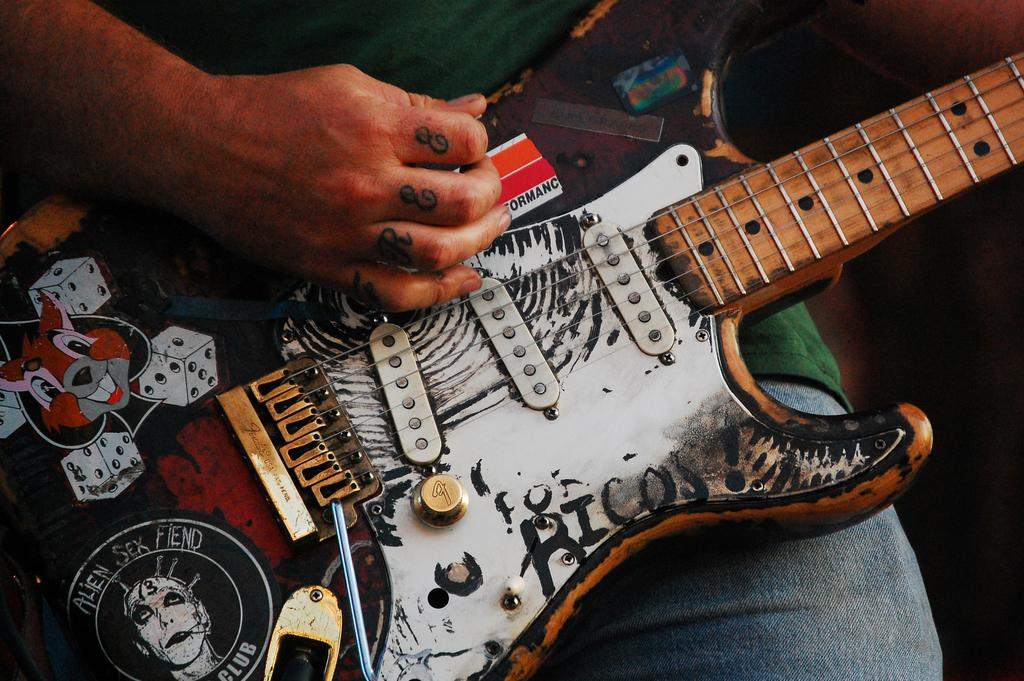What is the main subject of the image? There is a person in the image. What is the person holding in the image? The person is holding a guitar. What is the person doing with the guitar? The person is playing the guitar. What color is the shirt the person is wearing? The person is wearing a green color shirt. What type of sock is the person wearing in the image? There is no mention of socks in the image or the provided facts. 